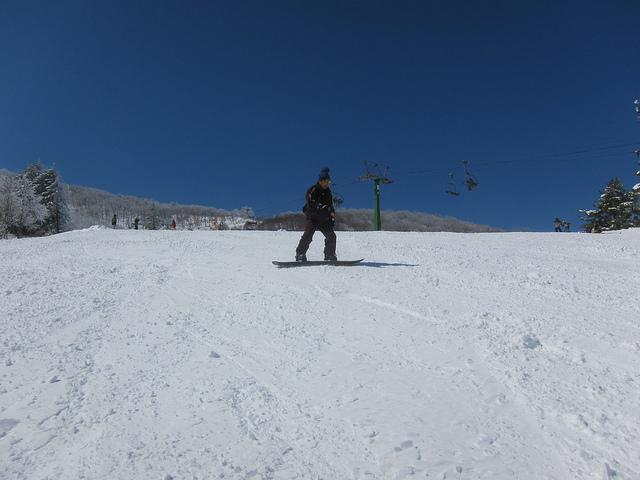Are the clouds in the sky?
Quick response, please. No. What is blue in the picture?
Keep it brief. Sky. Is this photo likely manipulated?
Answer briefly. No. How many skiers are there?
Short answer required. 1. Is this cross country skiing?
Give a very brief answer. No. What sport is the person partaking in?
Short answer required. Snowboarding. How many people are there in the photo?
Keep it brief. 1. What type of weather is this?
Be succinct. Cold. What time of day is the person skiing in?
Be succinct. Daytime. Is there a white cloud in the sky?
Answer briefly. No. Is it snowing?
Concise answer only. No. Is it a sunny day?
Give a very brief answer. Yes. What is in the person's hands?
Give a very brief answer. Nothing. Is there sun in the sky?
Give a very brief answer. Yes. What sport are they engaging in?
Be succinct. Snowboarding. Is it raining?
Be succinct. No. What are the men doing?
Give a very brief answer. Snowboarding. What color is the snowboard?
Be succinct. Black. Are there clouds in the sky?
Be succinct. No. 